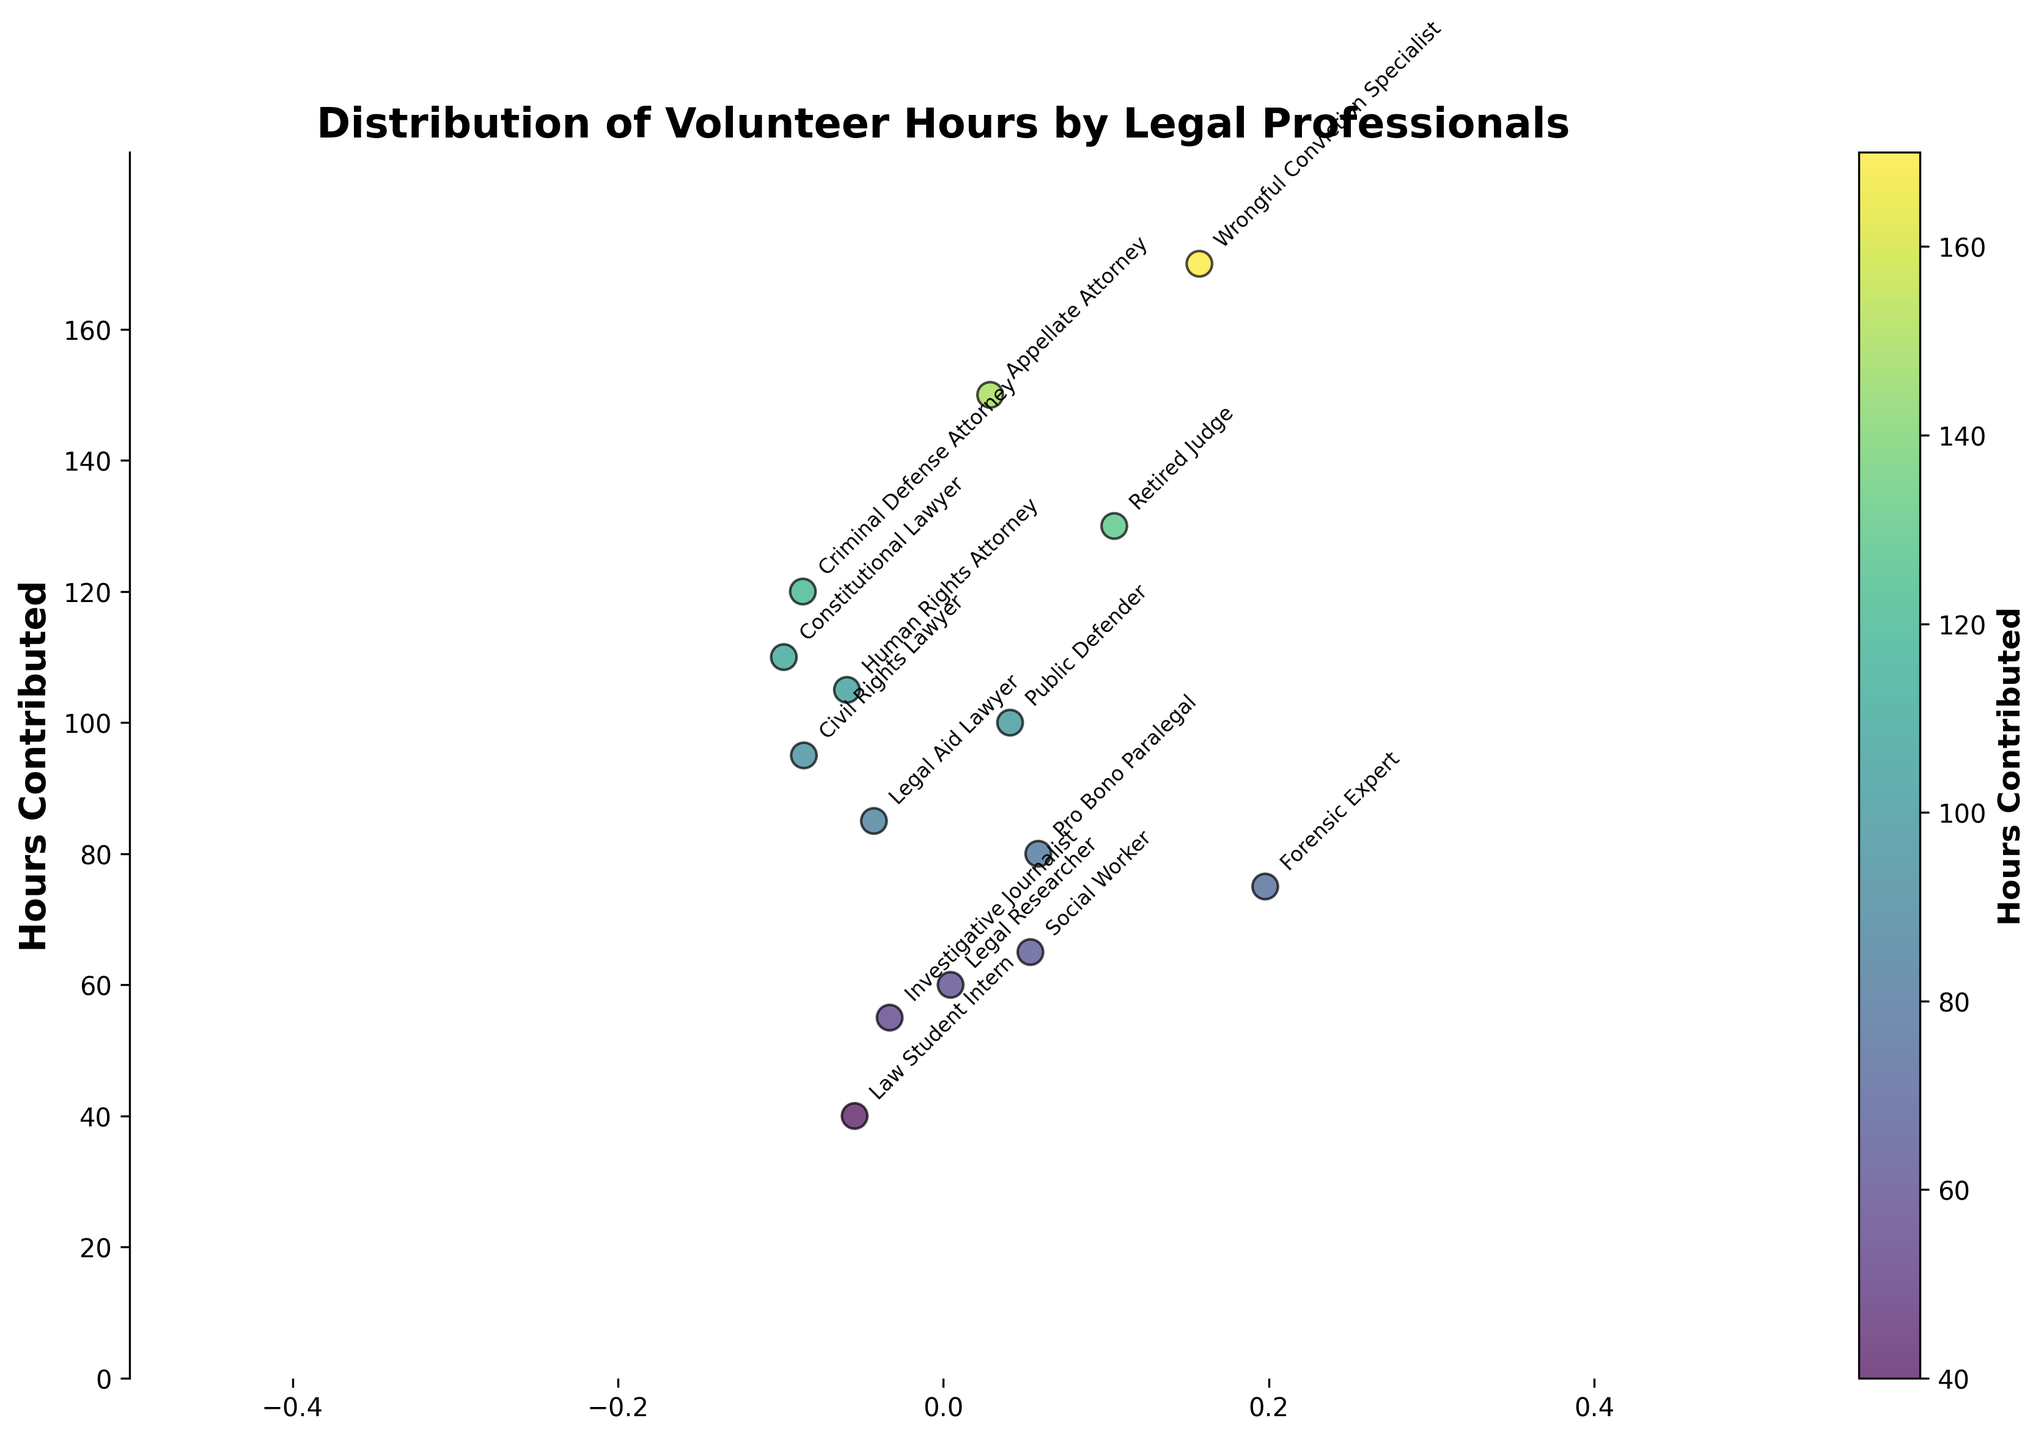How many different volunteer types are shown in the figure? To find the number of different volunteer types, we can count the unique labels annotated on the figure.
Answer: 15 What is the title of the figure? The title of the figure is displayed at the top of the plot.
Answer: Distribution of Volunteer Hours by Legal Professionals Which volunteer type contributed the highest number of hours? By observing the y-axis and identifying the data point that is positioned the highest, we can find the volunteer type annotated near that data point.
Answer: Wrongful Conviction Specialist What is the average number of hours contributed by the volunteers? To find the average, sum all the hours contributed by each volunteer type and then divide by the number of volunteer types. The sum is 1435 hours, and there are 15 volunteer types, so the average is 1435/15.
Answer: 95.67 Is there a volunteer type that contributed between 100 and 110 hours? By looking at the y-axis between 100 and 110 and checking for any data points within this range, we identify the annotated type.
Answer: Public Defender and Human Rights Attorney Which volunteer type contributed less than 50 hours? Examine the y-axis for data points under 50 hours and identify the associated volunteer type from annotations.
Answer: Law Student Intern How does the contribution of the Social Worker compare to that of the Forensic Expert? To compare, locate the data points for both the Social Worker and the Forensic Expert on the y-axis and compare their heights.
Answer: Social Worker contributed 65 hours while Forensic Expert contributed 75 hours What is the range of hours contributed by the volunteers? The range is calculated by finding the difference between the maximum and minimum hours contributed. The maximum is 170 hours, and the minimum is 40 hours, so the range is 170 - 40.
Answer: 130 How many volunteer types contributed more than 100 hours? Count the data points above 100 on the y-axis to find the number of volunteer types.
Answer: 6 What color represents a higher number of hours contributed on the plot's color scale? By examining the color bar on the right side of the plot, observe that higher numbers are associated with a specific color, typically moving from darker to lighter shades in the viridis color map.
Answer: Lighter colors 